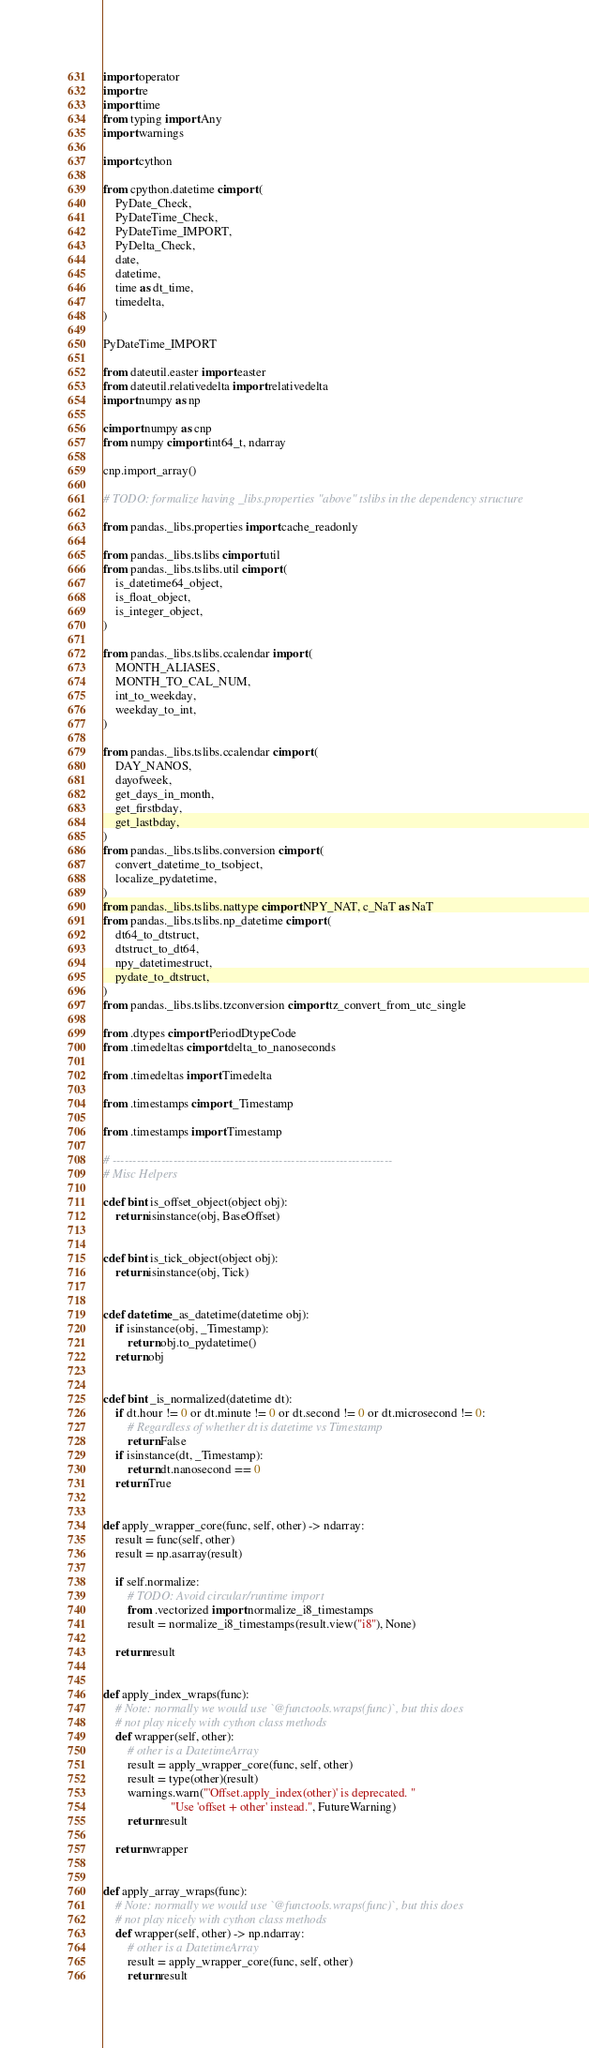<code> <loc_0><loc_0><loc_500><loc_500><_Cython_>import operator
import re
import time
from typing import Any
import warnings

import cython

from cpython.datetime cimport (
    PyDate_Check,
    PyDateTime_Check,
    PyDateTime_IMPORT,
    PyDelta_Check,
    date,
    datetime,
    time as dt_time,
    timedelta,
)

PyDateTime_IMPORT

from dateutil.easter import easter
from dateutil.relativedelta import relativedelta
import numpy as np

cimport numpy as cnp
from numpy cimport int64_t, ndarray

cnp.import_array()

# TODO: formalize having _libs.properties "above" tslibs in the dependency structure

from pandas._libs.properties import cache_readonly

from pandas._libs.tslibs cimport util
from pandas._libs.tslibs.util cimport (
    is_datetime64_object,
    is_float_object,
    is_integer_object,
)

from pandas._libs.tslibs.ccalendar import (
    MONTH_ALIASES,
    MONTH_TO_CAL_NUM,
    int_to_weekday,
    weekday_to_int,
)

from pandas._libs.tslibs.ccalendar cimport (
    DAY_NANOS,
    dayofweek,
    get_days_in_month,
    get_firstbday,
    get_lastbday,
)
from pandas._libs.tslibs.conversion cimport (
    convert_datetime_to_tsobject,
    localize_pydatetime,
)
from pandas._libs.tslibs.nattype cimport NPY_NAT, c_NaT as NaT
from pandas._libs.tslibs.np_datetime cimport (
    dt64_to_dtstruct,
    dtstruct_to_dt64,
    npy_datetimestruct,
    pydate_to_dtstruct,
)
from pandas._libs.tslibs.tzconversion cimport tz_convert_from_utc_single

from .dtypes cimport PeriodDtypeCode
from .timedeltas cimport delta_to_nanoseconds

from .timedeltas import Timedelta

from .timestamps cimport _Timestamp

from .timestamps import Timestamp

# ---------------------------------------------------------------------
# Misc Helpers

cdef bint is_offset_object(object obj):
    return isinstance(obj, BaseOffset)


cdef bint is_tick_object(object obj):
    return isinstance(obj, Tick)


cdef datetime _as_datetime(datetime obj):
    if isinstance(obj, _Timestamp):
        return obj.to_pydatetime()
    return obj


cdef bint _is_normalized(datetime dt):
    if dt.hour != 0 or dt.minute != 0 or dt.second != 0 or dt.microsecond != 0:
        # Regardless of whether dt is datetime vs Timestamp
        return False
    if isinstance(dt, _Timestamp):
        return dt.nanosecond == 0
    return True


def apply_wrapper_core(func, self, other) -> ndarray:
    result = func(self, other)
    result = np.asarray(result)

    if self.normalize:
        # TODO: Avoid circular/runtime import
        from .vectorized import normalize_i8_timestamps
        result = normalize_i8_timestamps(result.view("i8"), None)

    return result


def apply_index_wraps(func):
    # Note: normally we would use `@functools.wraps(func)`, but this does
    # not play nicely with cython class methods
    def wrapper(self, other):
        # other is a DatetimeArray
        result = apply_wrapper_core(func, self, other)
        result = type(other)(result)
        warnings.warn("'Offset.apply_index(other)' is deprecated. "
                      "Use 'offset + other' instead.", FutureWarning)
        return result

    return wrapper


def apply_array_wraps(func):
    # Note: normally we would use `@functools.wraps(func)`, but this does
    # not play nicely with cython class methods
    def wrapper(self, other) -> np.ndarray:
        # other is a DatetimeArray
        result = apply_wrapper_core(func, self, other)
        return result
</code> 